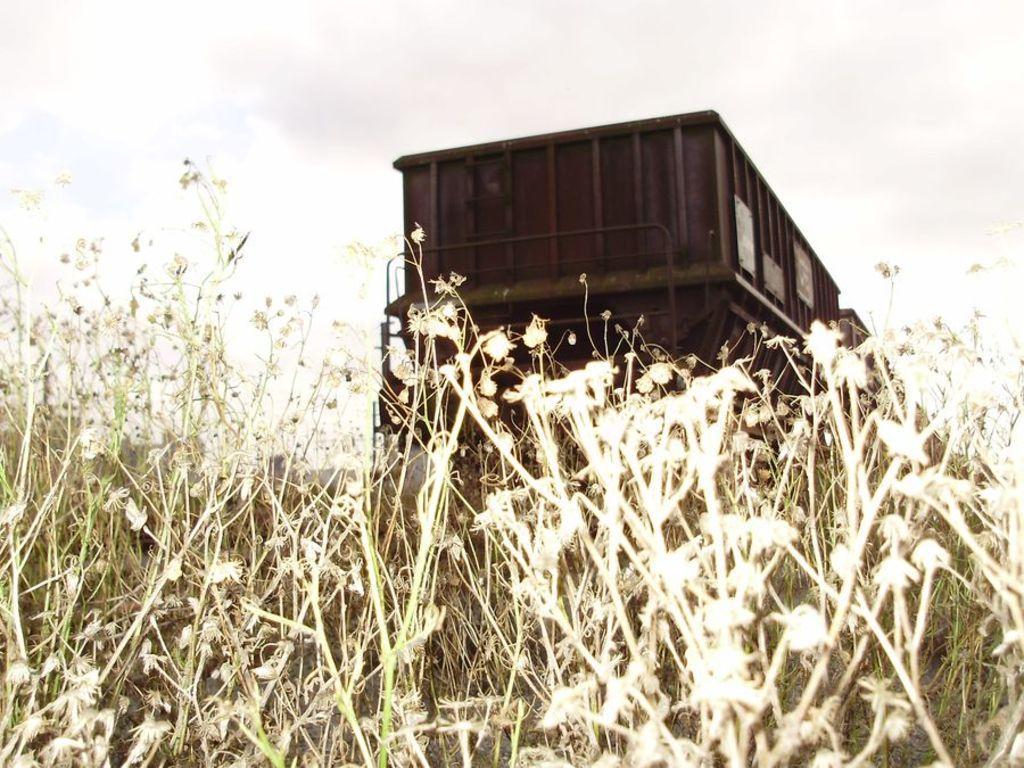How would you summarize this image in a sentence or two? In the image we can see goods wagon, grass and a cloudy sky. 